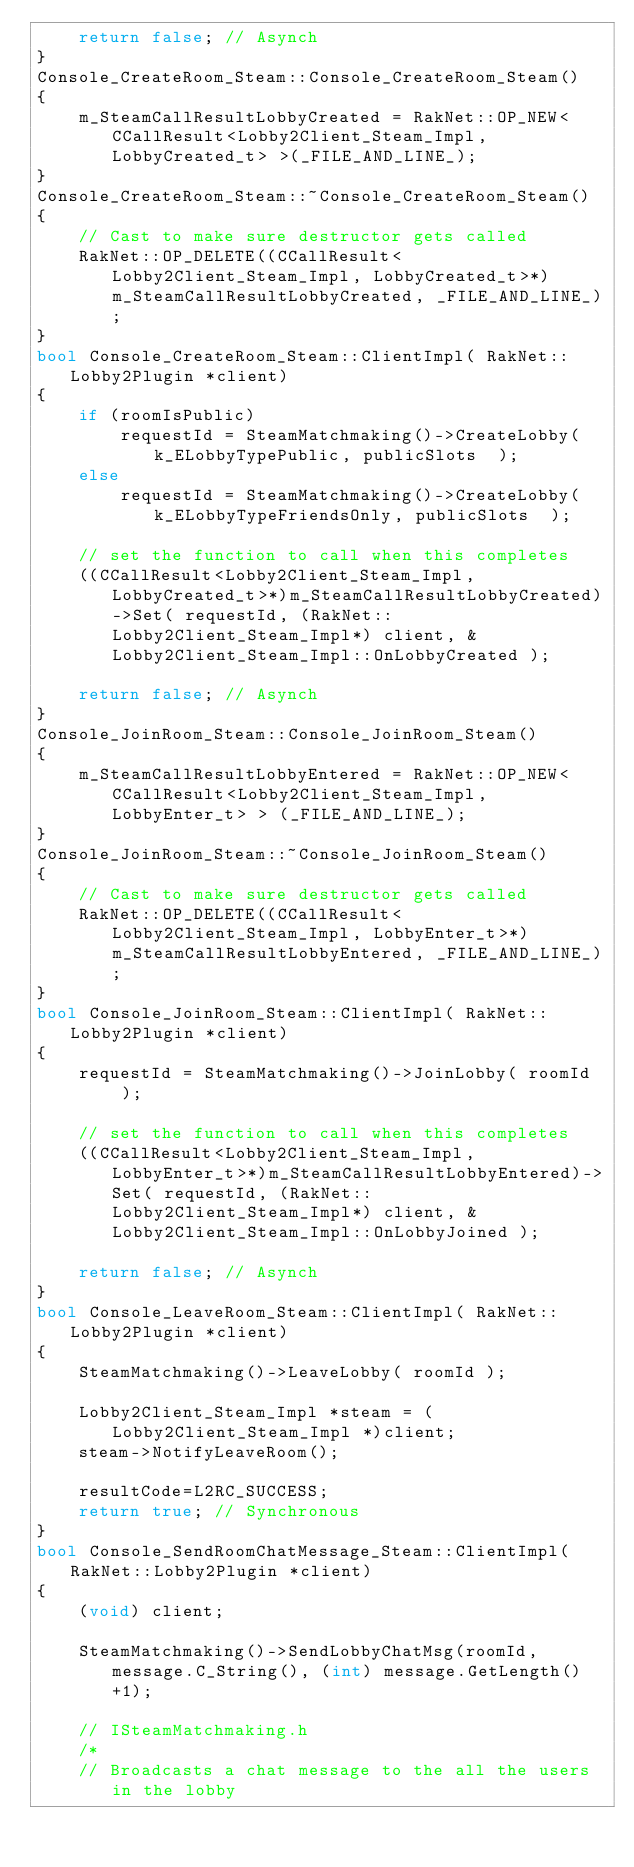Convert code to text. <code><loc_0><loc_0><loc_500><loc_500><_C++_>	return false; // Asynch
}
Console_CreateRoom_Steam::Console_CreateRoom_Steam()
{
	m_SteamCallResultLobbyCreated = RakNet::OP_NEW<CCallResult<Lobby2Client_Steam_Impl, LobbyCreated_t> >(_FILE_AND_LINE_);
}
Console_CreateRoom_Steam::~Console_CreateRoom_Steam()
{
	// Cast to make sure destructor gets called
	RakNet::OP_DELETE((CCallResult<Lobby2Client_Steam_Impl, LobbyCreated_t>*)m_SteamCallResultLobbyCreated, _FILE_AND_LINE_);
}
bool Console_CreateRoom_Steam::ClientImpl( RakNet::Lobby2Plugin *client)
{
	if (roomIsPublic)
		requestId = SteamMatchmaking()->CreateLobby( k_ELobbyTypePublic, publicSlots  );
	else
		requestId = SteamMatchmaking()->CreateLobby( k_ELobbyTypeFriendsOnly, publicSlots  );

	// set the function to call when this completes
	((CCallResult<Lobby2Client_Steam_Impl, LobbyCreated_t>*)m_SteamCallResultLobbyCreated)->Set( requestId, (RakNet::Lobby2Client_Steam_Impl*) client, &Lobby2Client_Steam_Impl::OnLobbyCreated );

	return false; // Asynch
}
Console_JoinRoom_Steam::Console_JoinRoom_Steam()
{
	m_SteamCallResultLobbyEntered = RakNet::OP_NEW<CCallResult<Lobby2Client_Steam_Impl, LobbyEnter_t> > (_FILE_AND_LINE_);
}
Console_JoinRoom_Steam::~Console_JoinRoom_Steam()
{
	// Cast to make sure destructor gets called
	RakNet::OP_DELETE((CCallResult<Lobby2Client_Steam_Impl, LobbyEnter_t>*)m_SteamCallResultLobbyEntered, _FILE_AND_LINE_);
}
bool Console_JoinRoom_Steam::ClientImpl( RakNet::Lobby2Plugin *client)
{
	requestId = SteamMatchmaking()->JoinLobby( roomId  );

	// set the function to call when this completes
	((CCallResult<Lobby2Client_Steam_Impl, LobbyEnter_t>*)m_SteamCallResultLobbyEntered)->Set( requestId, (RakNet::Lobby2Client_Steam_Impl*) client, &Lobby2Client_Steam_Impl::OnLobbyJoined );

	return false; // Asynch
}
bool Console_LeaveRoom_Steam::ClientImpl( RakNet::Lobby2Plugin *client)
{
	SteamMatchmaking()->LeaveLobby( roomId );

	Lobby2Client_Steam_Impl *steam = (Lobby2Client_Steam_Impl *)client;
	steam->NotifyLeaveRoom();

	resultCode=L2RC_SUCCESS;
	return true; // Synchronous
}
bool Console_SendRoomChatMessage_Steam::ClientImpl( RakNet::Lobby2Plugin *client)
{
	(void) client;

	SteamMatchmaking()->SendLobbyChatMsg(roomId, message.C_String(), (int) message.GetLength()+1);

	// ISteamMatchmaking.h
	/*
	// Broadcasts a chat message to the all the users in the lobby</code> 